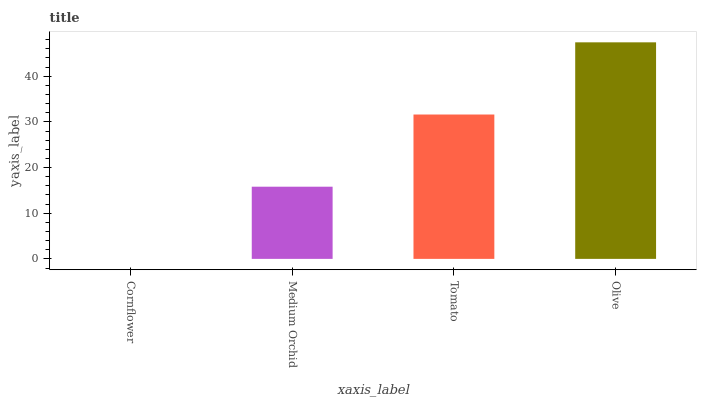Is Cornflower the minimum?
Answer yes or no. Yes. Is Olive the maximum?
Answer yes or no. Yes. Is Medium Orchid the minimum?
Answer yes or no. No. Is Medium Orchid the maximum?
Answer yes or no. No. Is Medium Orchid greater than Cornflower?
Answer yes or no. Yes. Is Cornflower less than Medium Orchid?
Answer yes or no. Yes. Is Cornflower greater than Medium Orchid?
Answer yes or no. No. Is Medium Orchid less than Cornflower?
Answer yes or no. No. Is Tomato the high median?
Answer yes or no. Yes. Is Medium Orchid the low median?
Answer yes or no. Yes. Is Cornflower the high median?
Answer yes or no. No. Is Tomato the low median?
Answer yes or no. No. 